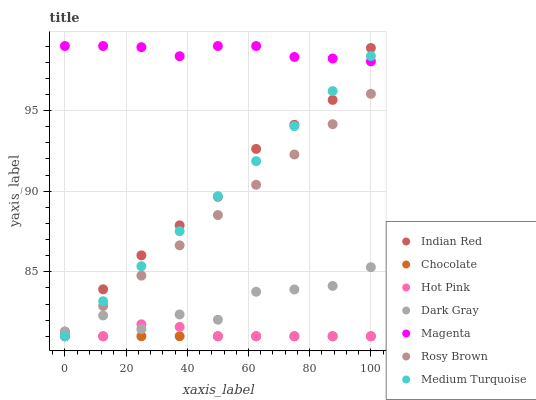Does Chocolate have the minimum area under the curve?
Answer yes or no. Yes. Does Magenta have the maximum area under the curve?
Answer yes or no. Yes. Does Medium Turquoise have the minimum area under the curve?
Answer yes or no. No. Does Medium Turquoise have the maximum area under the curve?
Answer yes or no. No. Is Chocolate the smoothest?
Answer yes or no. Yes. Is Dark Gray the roughest?
Answer yes or no. Yes. Is Medium Turquoise the smoothest?
Answer yes or no. No. Is Medium Turquoise the roughest?
Answer yes or no. No. Does Rosy Brown have the lowest value?
Answer yes or no. Yes. Does Dark Gray have the lowest value?
Answer yes or no. No. Does Magenta have the highest value?
Answer yes or no. Yes. Does Medium Turquoise have the highest value?
Answer yes or no. No. Is Chocolate less than Magenta?
Answer yes or no. Yes. Is Magenta greater than Rosy Brown?
Answer yes or no. Yes. Does Medium Turquoise intersect Dark Gray?
Answer yes or no. Yes. Is Medium Turquoise less than Dark Gray?
Answer yes or no. No. Is Medium Turquoise greater than Dark Gray?
Answer yes or no. No. Does Chocolate intersect Magenta?
Answer yes or no. No. 